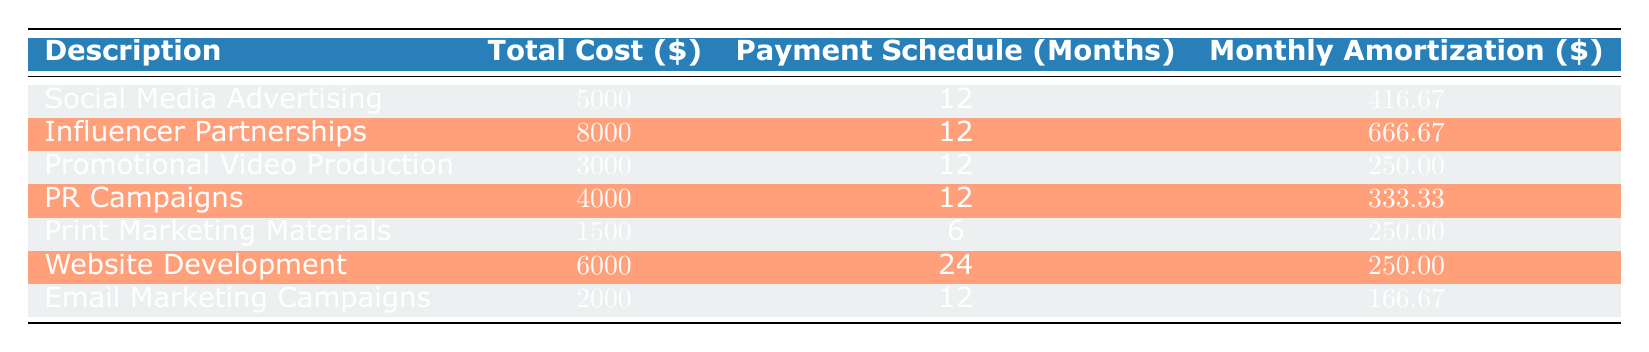What is the total cost of Social Media Advertising? The table lists the description "Social Media Advertising" with a corresponding total cost of 5000.
Answer: 5000 How many months is the payment schedule for Influencer Partnerships? The payment schedule for "Influencer Partnerships" is shown as 12 months in the table.
Answer: 12 What is the total monthly amortization for all marketing costs combined? To find the total monthly amortization, sum the monthly amortizations: 416.67 + 666.67 + 250.00 + 333.33 + 250.00 + 250.00 + 166.67 = 2083.34.
Answer: 2083.34 Is the total cost of the PR Campaigns higher than that of the Promotional Video Production? The total cost for "PR Campaigns" is 4000, whereas for "Promotional Video Production" it is 3000. Therefore, 4000 is greater than 3000, confirming the statement is true.
Answer: Yes What is the average payment schedule duration for all marketing costs? To find the average payment schedule, sum the payment schedules: 12 + 12 + 12 + 12 + 6 + 24 + 12 = 90. There are 7 entries, so the average is 90 / 7 = approximately 12.86 months.
Answer: 12.86 Are Email Marketing Campaigns less expensive than Print Marketing Materials? The total cost for "Email Marketing Campaigns" is 2000 and for "Print Marketing Materials" it is 1500. Since 2000 is greater than 1500, the statement is false.
Answer: No What is the difference in the monthly amortization between Influencer Partnerships and Email Marketing Campaigns? The monthly amortization for "Influencer Partnerships" is 666.67 and for "Email Marketing Campaigns" it is 166.67. The difference is 666.67 - 166.67 = 500.00.
Answer: 500.00 Which marketing cost has the longest payment schedule? The longest payment schedule is for "Website Development," which has a duration of 24 months according to the table.
Answer: Website Development What is the total cost for marketing materials (Print Marketing Materials and Promotional Video Production)? The total cost of "Print Marketing Materials" is 1500 and "Promotional Video Production" is 3000. Summing these gives 1500 + 3000 = 4500.
Answer: 4500 How many marketing costs have a monthly amortization greater than 250? The monthly amortizations greater than 250 are for "Social Media Advertising" (416.67), "Influencer Partnerships" (666.67), and "PR Campaigns" (333.33). That counts to 3 costs.
Answer: 3 